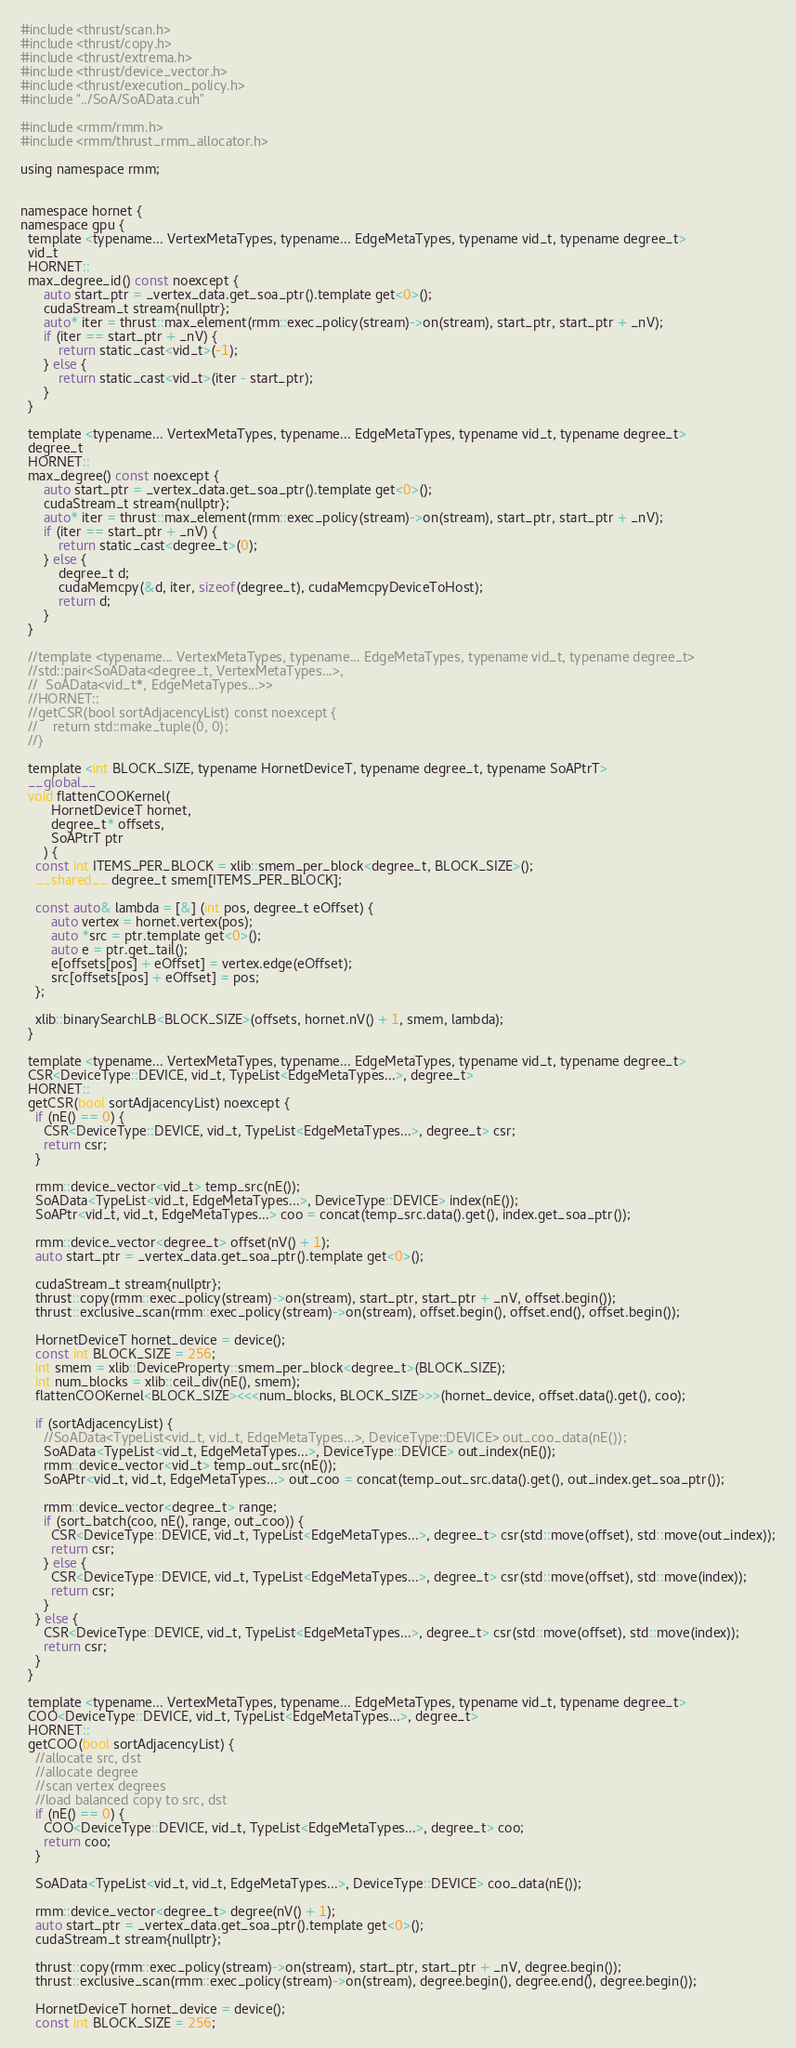Convert code to text. <code><loc_0><loc_0><loc_500><loc_500><_Cuda_>#include <thrust/scan.h>
#include <thrust/copy.h>
#include <thrust/extrema.h>
#include <thrust/device_vector.h>
#include <thrust/execution_policy.h>
#include "../SoA/SoAData.cuh"

#include <rmm/rmm.h>
#include <rmm/thrust_rmm_allocator.h>

using namespace rmm;


namespace hornet {
namespace gpu {
  template <typename... VertexMetaTypes, typename... EdgeMetaTypes, typename vid_t, typename degree_t>
  vid_t
  HORNET::
  max_degree_id() const noexcept {
      auto start_ptr = _vertex_data.get_soa_ptr().template get<0>();
      cudaStream_t stream{nullptr};
      auto* iter = thrust::max_element(rmm::exec_policy(stream)->on(stream), start_ptr, start_ptr + _nV);
      if (iter == start_ptr + _nV) {
          return static_cast<vid_t>(-1);
      } else {
          return static_cast<vid_t>(iter - start_ptr);
      }
  }

  template <typename... VertexMetaTypes, typename... EdgeMetaTypes, typename vid_t, typename degree_t>
  degree_t
  HORNET::
  max_degree() const noexcept {
      auto start_ptr = _vertex_data.get_soa_ptr().template get<0>();
      cudaStream_t stream{nullptr};
      auto* iter = thrust::max_element(rmm::exec_policy(stream)->on(stream), start_ptr, start_ptr + _nV);
      if (iter == start_ptr + _nV) {
          return static_cast<degree_t>(0);
      } else {
          degree_t d;
          cudaMemcpy(&d, iter, sizeof(degree_t), cudaMemcpyDeviceToHost);
          return d;
      }
  }

  //template <typename... VertexMetaTypes, typename... EdgeMetaTypes, typename vid_t, typename degree_t>
  //std::pair<SoAData<degree_t, VertexMetaTypes...>,
  //  SoAData<vid_t*, EdgeMetaTypes...>>
  //HORNET::
  //getCSR(bool sortAdjacencyList) const noexcept {
  //    return std::make_tuple(0, 0);
  //}

  template <int BLOCK_SIZE, typename HornetDeviceT, typename degree_t, typename SoAPtrT>
  __global__
  void flattenCOOKernel(
        HornetDeviceT hornet,
        degree_t* offsets,
        SoAPtrT ptr
      ) {
    const int ITEMS_PER_BLOCK = xlib::smem_per_block<degree_t, BLOCK_SIZE>();
    __shared__ degree_t smem[ITEMS_PER_BLOCK];

    const auto& lambda = [&] (int pos, degree_t eOffset) {
        auto vertex = hornet.vertex(pos);
        auto *src = ptr.template get<0>();
        auto e = ptr.get_tail();
        e[offsets[pos] + eOffset] = vertex.edge(eOffset);
        src[offsets[pos] + eOffset] = pos;
    };

    xlib::binarySearchLB<BLOCK_SIZE>(offsets, hornet.nV() + 1, smem, lambda);
  }

  template <typename... VertexMetaTypes, typename... EdgeMetaTypes, typename vid_t, typename degree_t>
  CSR<DeviceType::DEVICE, vid_t, TypeList<EdgeMetaTypes...>, degree_t>
  HORNET::
  getCSR(bool sortAdjacencyList) noexcept {
    if (nE() == 0) {
      CSR<DeviceType::DEVICE, vid_t, TypeList<EdgeMetaTypes...>, degree_t> csr;
      return csr;
    }

    rmm::device_vector<vid_t> temp_src(nE());
    SoAData<TypeList<vid_t, EdgeMetaTypes...>, DeviceType::DEVICE> index(nE());
    SoAPtr<vid_t, vid_t, EdgeMetaTypes...> coo = concat(temp_src.data().get(), index.get_soa_ptr());

    rmm::device_vector<degree_t> offset(nV() + 1);
    auto start_ptr = _vertex_data.get_soa_ptr().template get<0>();

    cudaStream_t stream{nullptr};
    thrust::copy(rmm::exec_policy(stream)->on(stream), start_ptr, start_ptr + _nV, offset.begin());
    thrust::exclusive_scan(rmm::exec_policy(stream)->on(stream), offset.begin(), offset.end(), offset.begin());

    HornetDeviceT hornet_device = device();
    const int BLOCK_SIZE = 256;
    int smem = xlib::DeviceProperty::smem_per_block<degree_t>(BLOCK_SIZE);
    int num_blocks = xlib::ceil_div(nE(), smem);
    flattenCOOKernel<BLOCK_SIZE><<<num_blocks, BLOCK_SIZE>>>(hornet_device, offset.data().get(), coo);

    if (sortAdjacencyList) {
      //SoAData<TypeList<vid_t, vid_t, EdgeMetaTypes...>, DeviceType::DEVICE> out_coo_data(nE());
      SoAData<TypeList<vid_t, EdgeMetaTypes...>, DeviceType::DEVICE> out_index(nE());
      rmm::device_vector<vid_t> temp_out_src(nE());
      SoAPtr<vid_t, vid_t, EdgeMetaTypes...> out_coo = concat(temp_out_src.data().get(), out_index.get_soa_ptr());

      rmm::device_vector<degree_t> range;
      if (sort_batch(coo, nE(), range, out_coo)) {
        CSR<DeviceType::DEVICE, vid_t, TypeList<EdgeMetaTypes...>, degree_t> csr(std::move(offset), std::move(out_index));
        return csr;
      } else {
        CSR<DeviceType::DEVICE, vid_t, TypeList<EdgeMetaTypes...>, degree_t> csr(std::move(offset), std::move(index));
        return csr;
      }
    } else {
      CSR<DeviceType::DEVICE, vid_t, TypeList<EdgeMetaTypes...>, degree_t> csr(std::move(offset), std::move(index));
      return csr;
    }
  }

  template <typename... VertexMetaTypes, typename... EdgeMetaTypes, typename vid_t, typename degree_t>
  COO<DeviceType::DEVICE, vid_t, TypeList<EdgeMetaTypes...>, degree_t>
  HORNET::
  getCOO(bool sortAdjacencyList) {
    //allocate src, dst
    //allocate degree
    //scan vertex degrees
    //load balanced copy to src, dst
    if (nE() == 0) {
      COO<DeviceType::DEVICE, vid_t, TypeList<EdgeMetaTypes...>, degree_t> coo;
      return coo;
    }

    SoAData<TypeList<vid_t, vid_t, EdgeMetaTypes...>, DeviceType::DEVICE> coo_data(nE());

    rmm::device_vector<degree_t> degree(nV() + 1);
    auto start_ptr = _vertex_data.get_soa_ptr().template get<0>();
    cudaStream_t stream{nullptr};

    thrust::copy(rmm::exec_policy(stream)->on(stream), start_ptr, start_ptr + _nV, degree.begin());
    thrust::exclusive_scan(rmm::exec_policy(stream)->on(stream), degree.begin(), degree.end(), degree.begin());

    HornetDeviceT hornet_device = device();
    const int BLOCK_SIZE = 256;</code> 